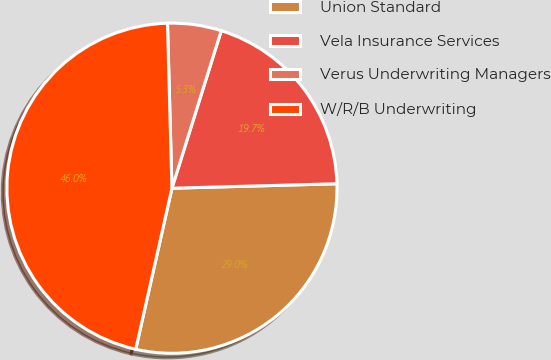Convert chart. <chart><loc_0><loc_0><loc_500><loc_500><pie_chart><fcel>Union Standard<fcel>Vela Insurance Services<fcel>Verus Underwriting Managers<fcel>W/R/B Underwriting<nl><fcel>28.95%<fcel>19.74%<fcel>5.26%<fcel>46.05%<nl></chart> 